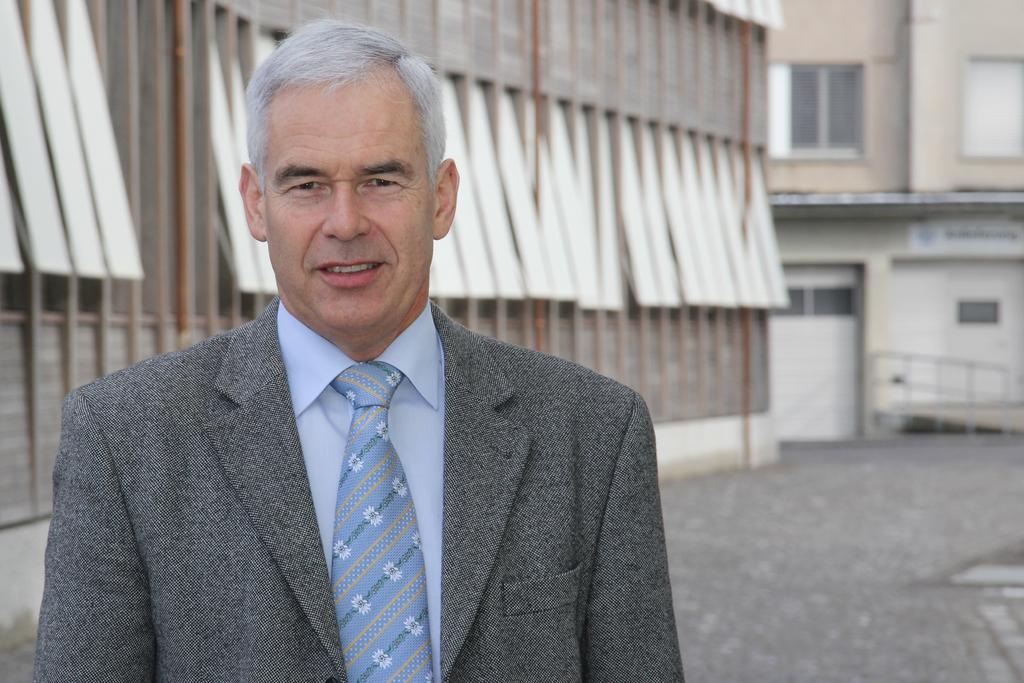What is the main subject of the image? There is a person in the image. What is the person doing in the image? The person is standing. How does the person appear to be feeling in the image? The person has a smile on their face, suggesting they are happy or content. What can be seen in the background of the image? There are buildings visible in the background of the image. What type of brake can be seen on the person's shoes in the image? There is no brake visible on the person's shoes in the image. What reward is the person holding in their hand in the image? There is no reward visible in the person's hand in the image. 